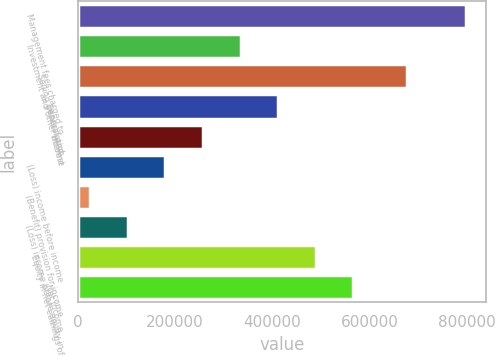<chart> <loc_0><loc_0><loc_500><loc_500><bar_chart><fcel>Management fees charged to<fcel>Investment and other income<fcel>Selling general and<fcel>Depreciation<fcel>Interest<fcel>(Loss) income before income<fcel>(Benefit) provision for income<fcel>(Loss) income before equity in<fcel>Equity in net earnings of<fcel>Net income<nl><fcel>798472<fcel>334497<fcel>676613<fcel>411826<fcel>257168<fcel>179839<fcel>25181<fcel>102510<fcel>489156<fcel>566485<nl></chart> 